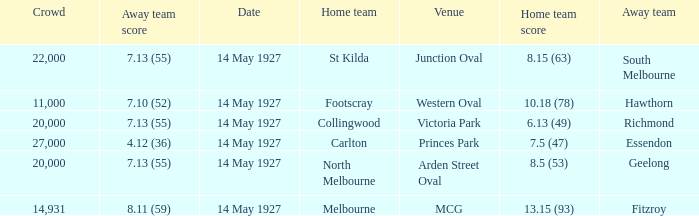Which away team had a score of 4.12 (36)? Essendon. 